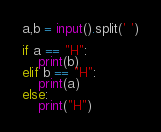Convert code to text. <code><loc_0><loc_0><loc_500><loc_500><_Python_>a,b = input().split(' ')
 
if a == "H":
    print(b)
elif b == "H":
    print(a)
else:
    print("H")</code> 